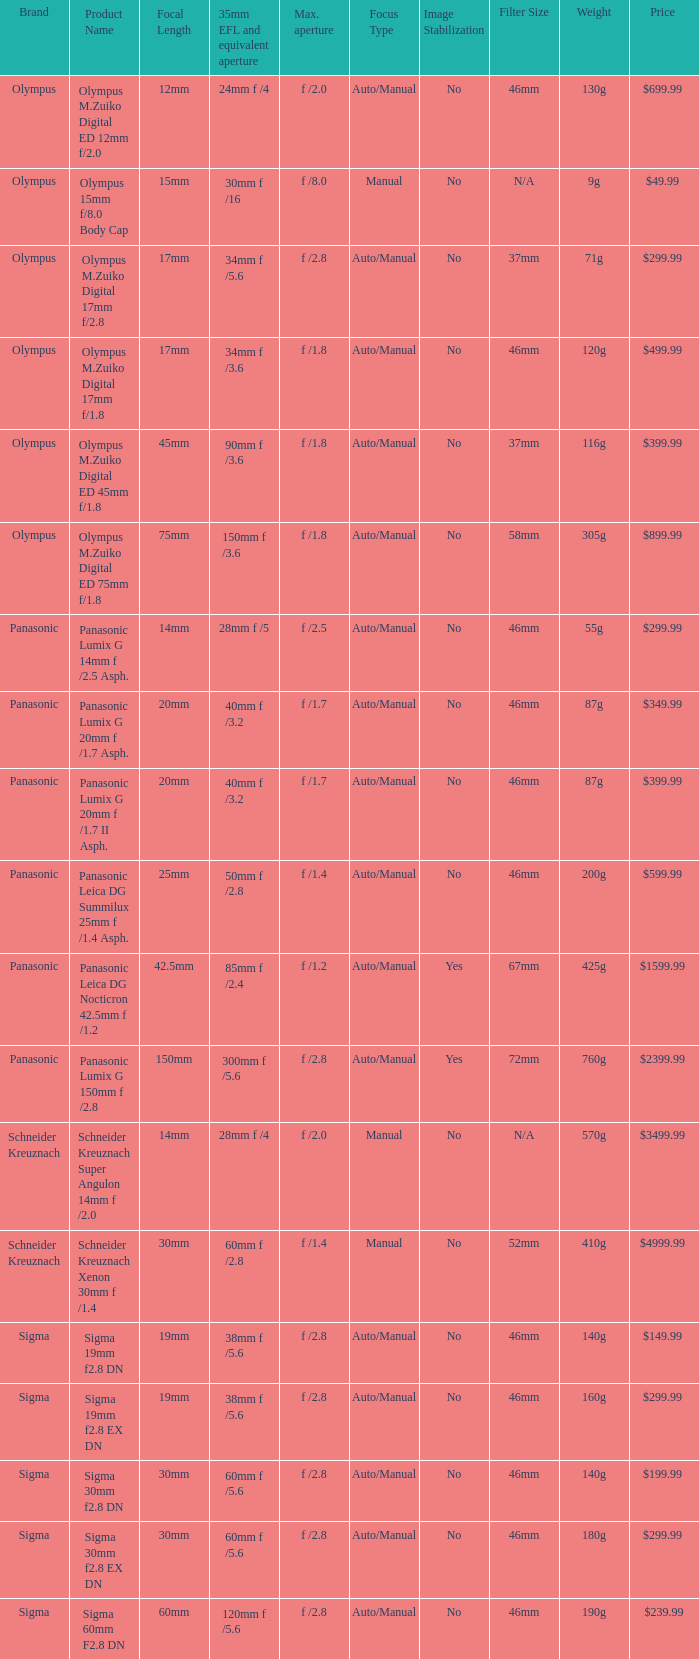What is the 35mm EFL and the equivalent aperture of the lens(es) with a maximum aperture of f /2.5? 28mm f /5. 